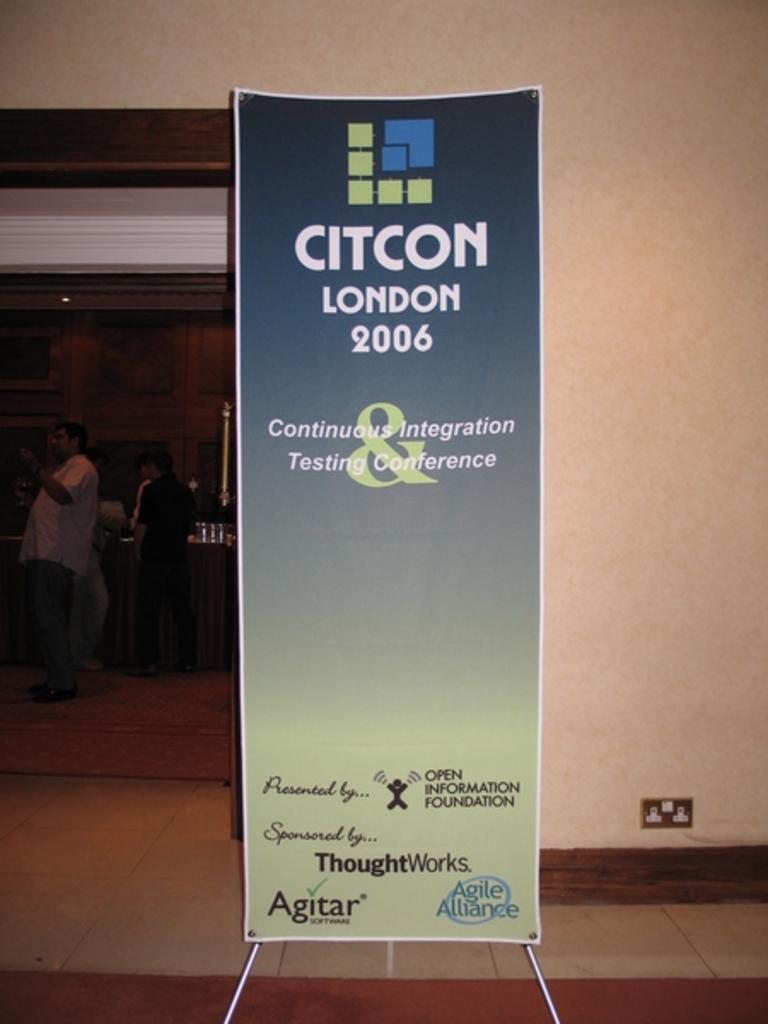Who or what can be seen in the image? There are people in the image. What is the background of the image? There is a wall in the image. What object is present in the image besides the wall and people? There is a board in the image. What is written or displayed on the board? Something is written on the board. Can you see a pig standing in line with the people in the image? No, there is no pig or line present in the image. What type of flesh is visible on the people in the image? There is no flesh visible on the people in the image; it is a photograph or illustration, not a physical representation. 